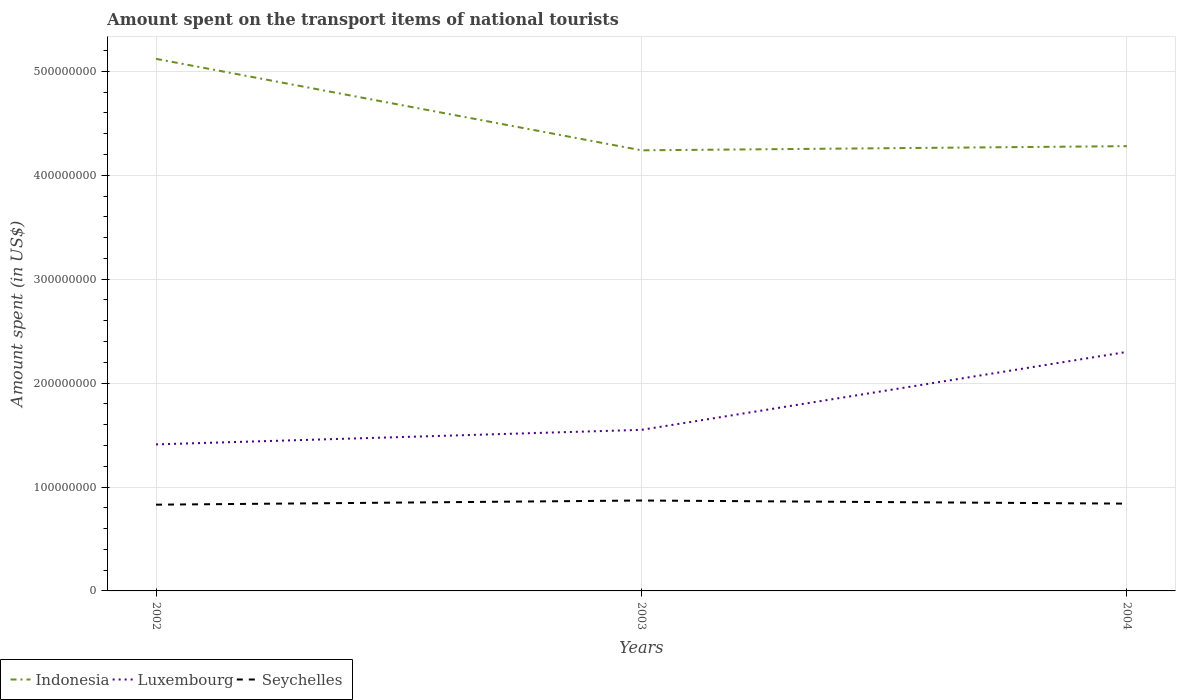Does the line corresponding to Luxembourg intersect with the line corresponding to Indonesia?
Make the answer very short. No. Is the number of lines equal to the number of legend labels?
Your answer should be very brief. Yes. Across all years, what is the maximum amount spent on the transport items of national tourists in Seychelles?
Give a very brief answer. 8.30e+07. What is the total amount spent on the transport items of national tourists in Seychelles in the graph?
Offer a very short reply. 3.00e+06. What is the difference between the highest and the second highest amount spent on the transport items of national tourists in Indonesia?
Your answer should be very brief. 8.80e+07. Is the amount spent on the transport items of national tourists in Seychelles strictly greater than the amount spent on the transport items of national tourists in Indonesia over the years?
Your response must be concise. Yes. How many lines are there?
Provide a short and direct response. 3. Are the values on the major ticks of Y-axis written in scientific E-notation?
Your answer should be very brief. No. Does the graph contain grids?
Ensure brevity in your answer.  Yes. What is the title of the graph?
Your answer should be compact. Amount spent on the transport items of national tourists. What is the label or title of the Y-axis?
Keep it short and to the point. Amount spent (in US$). What is the Amount spent (in US$) in Indonesia in 2002?
Give a very brief answer. 5.12e+08. What is the Amount spent (in US$) in Luxembourg in 2002?
Give a very brief answer. 1.41e+08. What is the Amount spent (in US$) of Seychelles in 2002?
Provide a succinct answer. 8.30e+07. What is the Amount spent (in US$) of Indonesia in 2003?
Provide a short and direct response. 4.24e+08. What is the Amount spent (in US$) of Luxembourg in 2003?
Provide a succinct answer. 1.55e+08. What is the Amount spent (in US$) of Seychelles in 2003?
Offer a terse response. 8.70e+07. What is the Amount spent (in US$) in Indonesia in 2004?
Give a very brief answer. 4.28e+08. What is the Amount spent (in US$) in Luxembourg in 2004?
Provide a succinct answer. 2.30e+08. What is the Amount spent (in US$) in Seychelles in 2004?
Make the answer very short. 8.40e+07. Across all years, what is the maximum Amount spent (in US$) of Indonesia?
Offer a very short reply. 5.12e+08. Across all years, what is the maximum Amount spent (in US$) in Luxembourg?
Give a very brief answer. 2.30e+08. Across all years, what is the maximum Amount spent (in US$) in Seychelles?
Offer a terse response. 8.70e+07. Across all years, what is the minimum Amount spent (in US$) of Indonesia?
Offer a very short reply. 4.24e+08. Across all years, what is the minimum Amount spent (in US$) of Luxembourg?
Make the answer very short. 1.41e+08. Across all years, what is the minimum Amount spent (in US$) of Seychelles?
Your response must be concise. 8.30e+07. What is the total Amount spent (in US$) of Indonesia in the graph?
Provide a succinct answer. 1.36e+09. What is the total Amount spent (in US$) in Luxembourg in the graph?
Keep it short and to the point. 5.26e+08. What is the total Amount spent (in US$) in Seychelles in the graph?
Provide a succinct answer. 2.54e+08. What is the difference between the Amount spent (in US$) of Indonesia in 2002 and that in 2003?
Offer a very short reply. 8.80e+07. What is the difference between the Amount spent (in US$) of Luxembourg in 2002 and that in 2003?
Make the answer very short. -1.40e+07. What is the difference between the Amount spent (in US$) of Seychelles in 2002 and that in 2003?
Provide a succinct answer. -4.00e+06. What is the difference between the Amount spent (in US$) in Indonesia in 2002 and that in 2004?
Provide a short and direct response. 8.40e+07. What is the difference between the Amount spent (in US$) in Luxembourg in 2002 and that in 2004?
Provide a succinct answer. -8.90e+07. What is the difference between the Amount spent (in US$) in Luxembourg in 2003 and that in 2004?
Your answer should be compact. -7.50e+07. What is the difference between the Amount spent (in US$) in Seychelles in 2003 and that in 2004?
Offer a very short reply. 3.00e+06. What is the difference between the Amount spent (in US$) in Indonesia in 2002 and the Amount spent (in US$) in Luxembourg in 2003?
Ensure brevity in your answer.  3.57e+08. What is the difference between the Amount spent (in US$) in Indonesia in 2002 and the Amount spent (in US$) in Seychelles in 2003?
Provide a succinct answer. 4.25e+08. What is the difference between the Amount spent (in US$) of Luxembourg in 2002 and the Amount spent (in US$) of Seychelles in 2003?
Give a very brief answer. 5.40e+07. What is the difference between the Amount spent (in US$) in Indonesia in 2002 and the Amount spent (in US$) in Luxembourg in 2004?
Provide a short and direct response. 2.82e+08. What is the difference between the Amount spent (in US$) of Indonesia in 2002 and the Amount spent (in US$) of Seychelles in 2004?
Your answer should be very brief. 4.28e+08. What is the difference between the Amount spent (in US$) of Luxembourg in 2002 and the Amount spent (in US$) of Seychelles in 2004?
Offer a very short reply. 5.70e+07. What is the difference between the Amount spent (in US$) in Indonesia in 2003 and the Amount spent (in US$) in Luxembourg in 2004?
Your response must be concise. 1.94e+08. What is the difference between the Amount spent (in US$) in Indonesia in 2003 and the Amount spent (in US$) in Seychelles in 2004?
Your answer should be compact. 3.40e+08. What is the difference between the Amount spent (in US$) in Luxembourg in 2003 and the Amount spent (in US$) in Seychelles in 2004?
Your answer should be very brief. 7.10e+07. What is the average Amount spent (in US$) in Indonesia per year?
Your answer should be compact. 4.55e+08. What is the average Amount spent (in US$) in Luxembourg per year?
Offer a very short reply. 1.75e+08. What is the average Amount spent (in US$) in Seychelles per year?
Provide a succinct answer. 8.47e+07. In the year 2002, what is the difference between the Amount spent (in US$) of Indonesia and Amount spent (in US$) of Luxembourg?
Make the answer very short. 3.71e+08. In the year 2002, what is the difference between the Amount spent (in US$) of Indonesia and Amount spent (in US$) of Seychelles?
Make the answer very short. 4.29e+08. In the year 2002, what is the difference between the Amount spent (in US$) in Luxembourg and Amount spent (in US$) in Seychelles?
Your answer should be very brief. 5.80e+07. In the year 2003, what is the difference between the Amount spent (in US$) in Indonesia and Amount spent (in US$) in Luxembourg?
Give a very brief answer. 2.69e+08. In the year 2003, what is the difference between the Amount spent (in US$) in Indonesia and Amount spent (in US$) in Seychelles?
Keep it short and to the point. 3.37e+08. In the year 2003, what is the difference between the Amount spent (in US$) of Luxembourg and Amount spent (in US$) of Seychelles?
Keep it short and to the point. 6.80e+07. In the year 2004, what is the difference between the Amount spent (in US$) of Indonesia and Amount spent (in US$) of Luxembourg?
Provide a succinct answer. 1.98e+08. In the year 2004, what is the difference between the Amount spent (in US$) in Indonesia and Amount spent (in US$) in Seychelles?
Your response must be concise. 3.44e+08. In the year 2004, what is the difference between the Amount spent (in US$) in Luxembourg and Amount spent (in US$) in Seychelles?
Your answer should be compact. 1.46e+08. What is the ratio of the Amount spent (in US$) in Indonesia in 2002 to that in 2003?
Your answer should be very brief. 1.21. What is the ratio of the Amount spent (in US$) in Luxembourg in 2002 to that in 2003?
Make the answer very short. 0.91. What is the ratio of the Amount spent (in US$) of Seychelles in 2002 to that in 2003?
Offer a terse response. 0.95. What is the ratio of the Amount spent (in US$) in Indonesia in 2002 to that in 2004?
Your answer should be compact. 1.2. What is the ratio of the Amount spent (in US$) in Luxembourg in 2002 to that in 2004?
Make the answer very short. 0.61. What is the ratio of the Amount spent (in US$) of Seychelles in 2002 to that in 2004?
Give a very brief answer. 0.99. What is the ratio of the Amount spent (in US$) in Luxembourg in 2003 to that in 2004?
Your response must be concise. 0.67. What is the ratio of the Amount spent (in US$) in Seychelles in 2003 to that in 2004?
Your answer should be compact. 1.04. What is the difference between the highest and the second highest Amount spent (in US$) in Indonesia?
Your answer should be very brief. 8.40e+07. What is the difference between the highest and the second highest Amount spent (in US$) in Luxembourg?
Provide a succinct answer. 7.50e+07. What is the difference between the highest and the lowest Amount spent (in US$) in Indonesia?
Offer a very short reply. 8.80e+07. What is the difference between the highest and the lowest Amount spent (in US$) in Luxembourg?
Make the answer very short. 8.90e+07. 